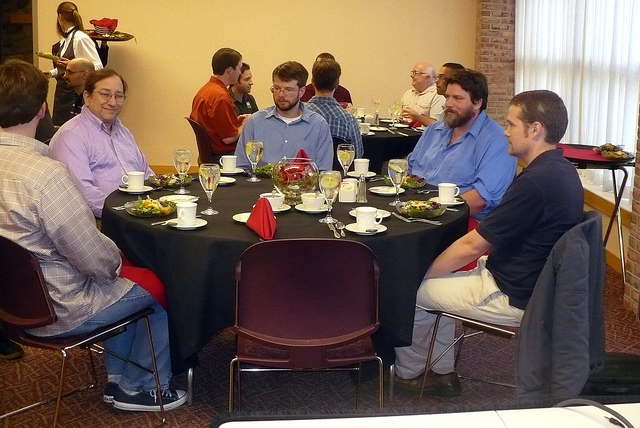Can you describe the mood at the table? While everyone has a unique expression, the overall ambiance suggests a relaxed and friendly environment. The participants appear to be engaged in comfortable dialogue, contributing to a congenial mood. 